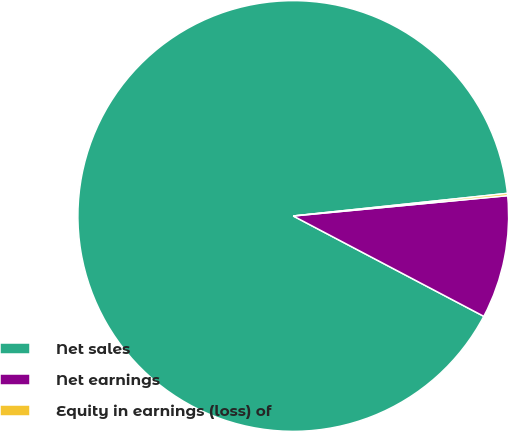Convert chart. <chart><loc_0><loc_0><loc_500><loc_500><pie_chart><fcel>Net sales<fcel>Net earnings<fcel>Equity in earnings (loss) of<nl><fcel>90.61%<fcel>9.22%<fcel>0.17%<nl></chart> 